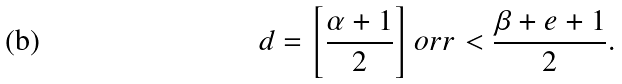Convert formula to latex. <formula><loc_0><loc_0><loc_500><loc_500>d = \left [ \frac { \alpha + 1 } { 2 } \right ] o r r < \frac { \beta + e + 1 } { 2 } .</formula> 